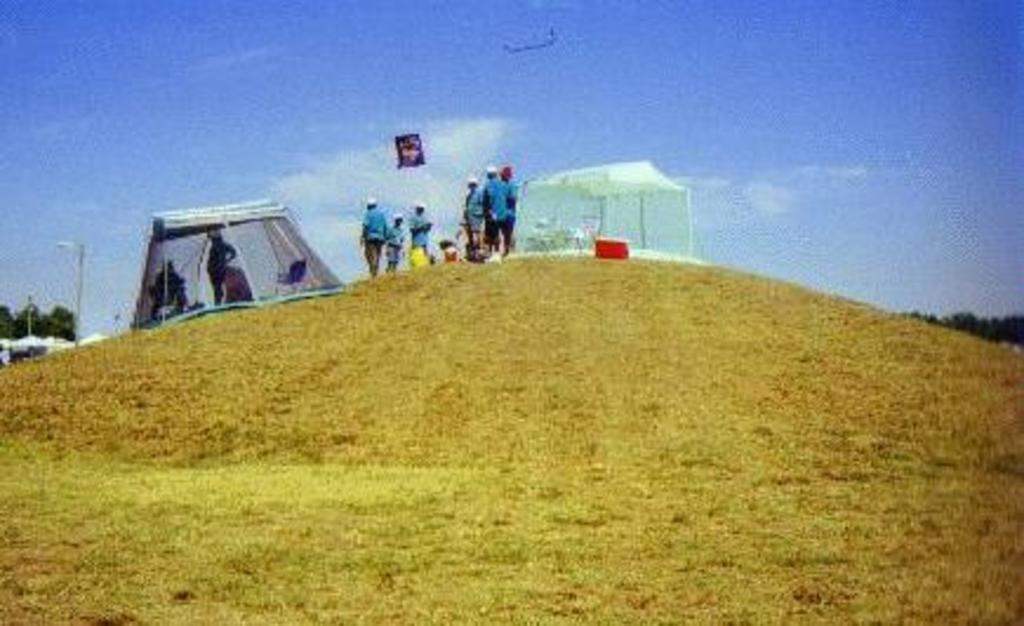Describe this image in one or two sentences. In the image we can see there are many people standing, wearing clothes and cap. This is a grass, light pole, tree, tent, box and a cloudy sky. 